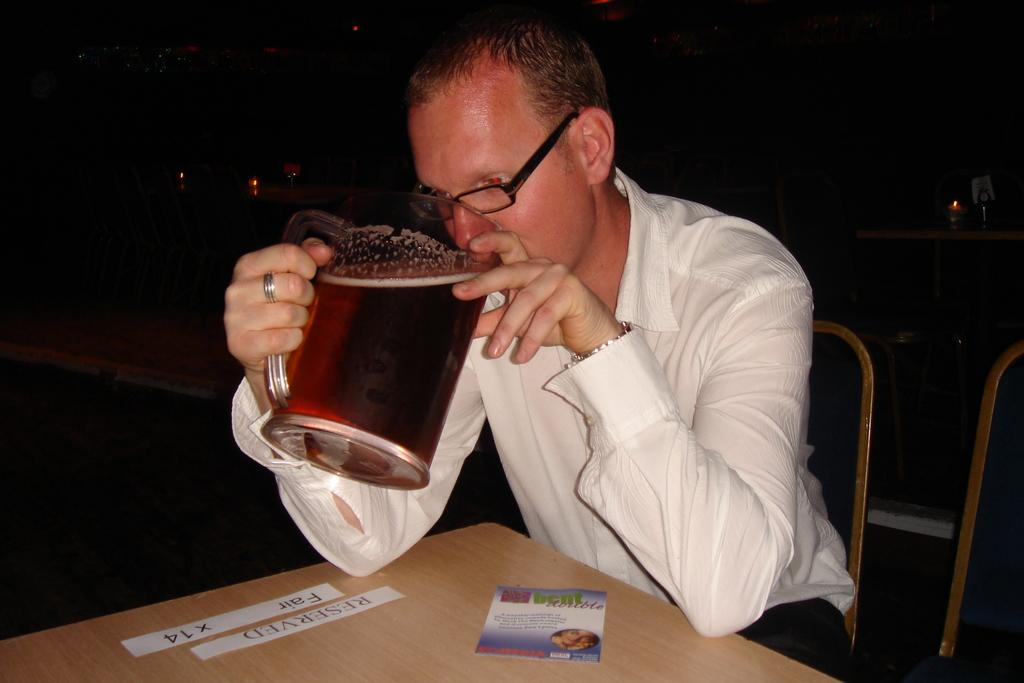Who is present in the image? There is a man in the image. What is the man doing in the image? The man is sitting on a chair in the image. What is the man holding in his hand? The man is holding a mug in his hand. What is in the mug? The mug contains wine. What piece of furniture is visible in the image? There is a table in the image. What type of trail can be seen in the image? There is no trail present in the image; it features a man sitting on a chair holding a mug of wine. 